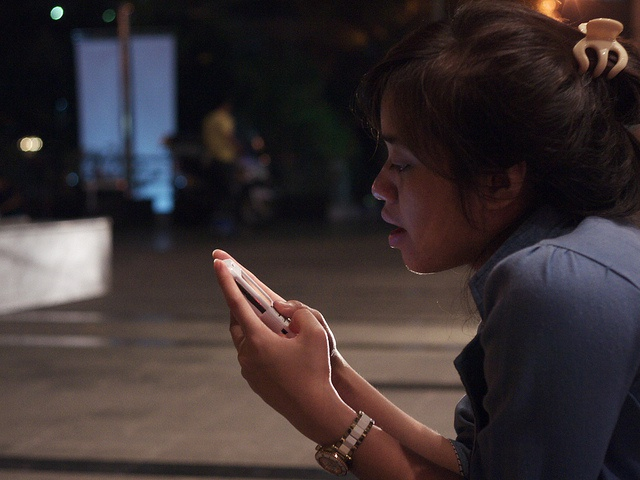Describe the objects in this image and their specific colors. I can see people in black, maroon, gray, and brown tones, people in black, maroon, and brown tones, people in black tones, cell phone in black, brown, lightgray, and maroon tones, and clock in black, maroon, gray, and brown tones in this image. 